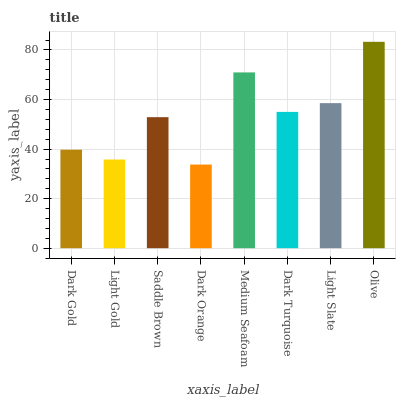Is Dark Orange the minimum?
Answer yes or no. Yes. Is Olive the maximum?
Answer yes or no. Yes. Is Light Gold the minimum?
Answer yes or no. No. Is Light Gold the maximum?
Answer yes or no. No. Is Dark Gold greater than Light Gold?
Answer yes or no. Yes. Is Light Gold less than Dark Gold?
Answer yes or no. Yes. Is Light Gold greater than Dark Gold?
Answer yes or no. No. Is Dark Gold less than Light Gold?
Answer yes or no. No. Is Dark Turquoise the high median?
Answer yes or no. Yes. Is Saddle Brown the low median?
Answer yes or no. Yes. Is Light Gold the high median?
Answer yes or no. No. Is Medium Seafoam the low median?
Answer yes or no. No. 